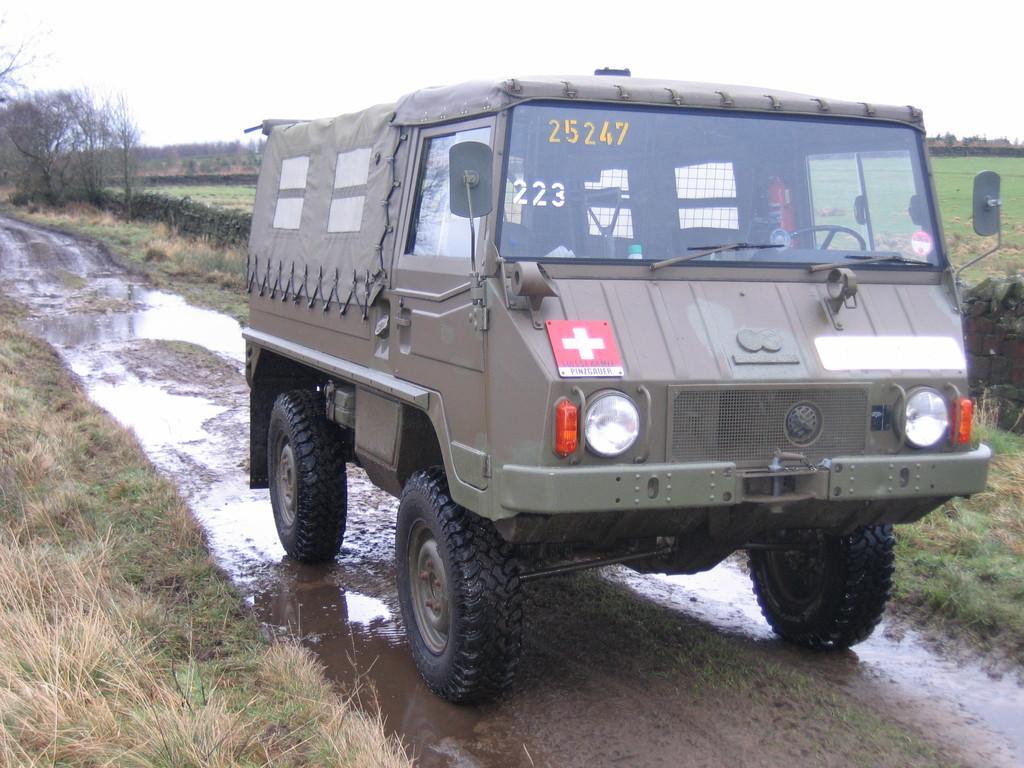Can you describe this image briefly? In this image we can see a vehicle. Here we can see ground, water, grass, plants, and trees. In the background there is sky. 